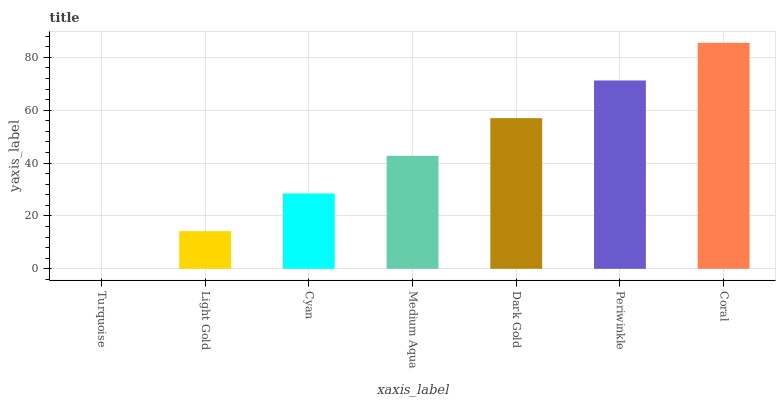Is Light Gold the minimum?
Answer yes or no. No. Is Light Gold the maximum?
Answer yes or no. No. Is Light Gold greater than Turquoise?
Answer yes or no. Yes. Is Turquoise less than Light Gold?
Answer yes or no. Yes. Is Turquoise greater than Light Gold?
Answer yes or no. No. Is Light Gold less than Turquoise?
Answer yes or no. No. Is Medium Aqua the high median?
Answer yes or no. Yes. Is Medium Aqua the low median?
Answer yes or no. Yes. Is Coral the high median?
Answer yes or no. No. Is Coral the low median?
Answer yes or no. No. 